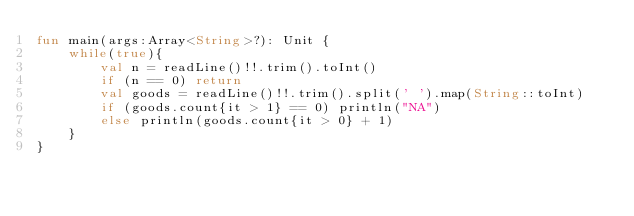Convert code to text. <code><loc_0><loc_0><loc_500><loc_500><_Kotlin_>fun main(args:Array<String>?): Unit {
    while(true){
        val n = readLine()!!.trim().toInt()
        if (n == 0) return
        val goods = readLine()!!.trim().split(' ').map(String::toInt)
        if (goods.count{it > 1} == 0) println("NA")
        else println(goods.count{it > 0} + 1)
    }
}
</code> 